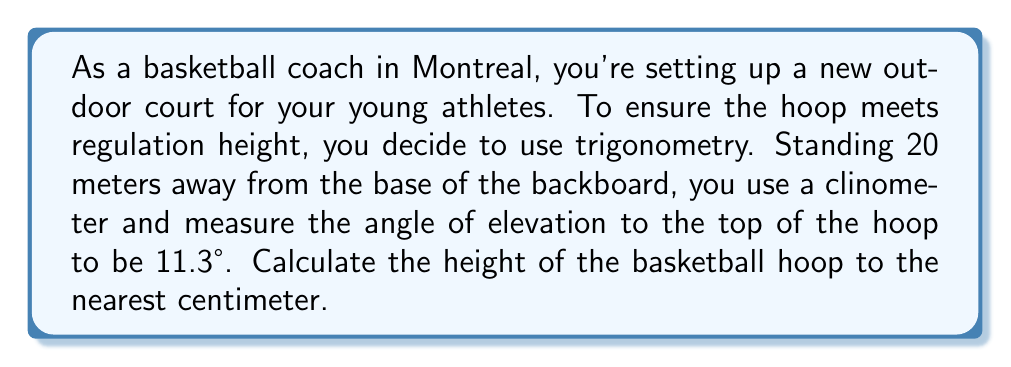Can you solve this math problem? Let's approach this step-by-step using trigonometry:

1) First, let's visualize the problem:

[asy]
import geometry;

pair A = (0,0), B = (20,0), C = (20,4);
draw(A--B--C--A);
label("20 m", (10,0), S);
label("h", (20,2), E);
label("11.3°", (1,0), NW);
draw(arc(A,1,0,11.3), Arrow);
[/asy]

2) In this right-angled triangle, we know:
   - The adjacent side (distance from you to the base of the hoop) = 20 meters
   - The angle of elevation = 11.3°
   - We need to find the opposite side (height of the hoop)

3) This scenario calls for the tangent function:

   $$\tan(\theta) = \frac{\text{opposite}}{\text{adjacent}}$$

4) Let's plug in our known values:

   $$\tan(11.3°) = \frac{h}{20}$$

   Where $h$ is the height we're trying to find.

5) To solve for $h$, multiply both sides by 20:

   $$20 \cdot \tan(11.3°) = h$$

6) Now, let's calculate:

   $$h = 20 \cdot \tan(11.3°) = 20 \cdot 0.19986 = 3.9972 \text{ meters}$$

7) Converting to centimeters and rounding to the nearest whole number:

   $$3.9972 \text{ m} \cdot 100 = 399.72 \text{ cm} \approx 400 \text{ cm}$$
Answer: 400 cm 